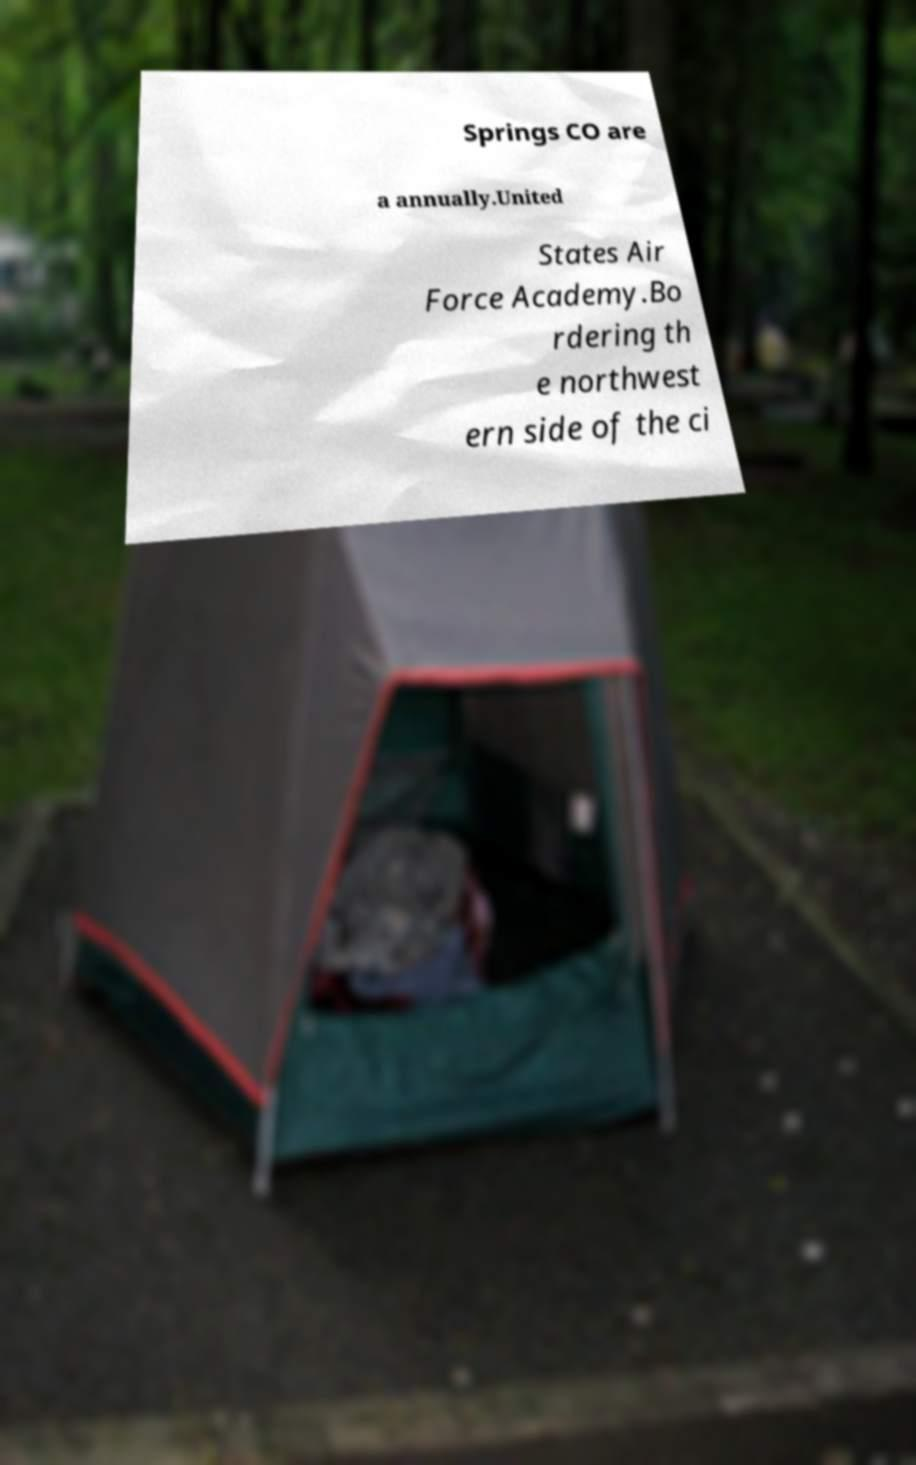Please read and relay the text visible in this image. What does it say? Springs CO are a annually.United States Air Force Academy.Bo rdering th e northwest ern side of the ci 